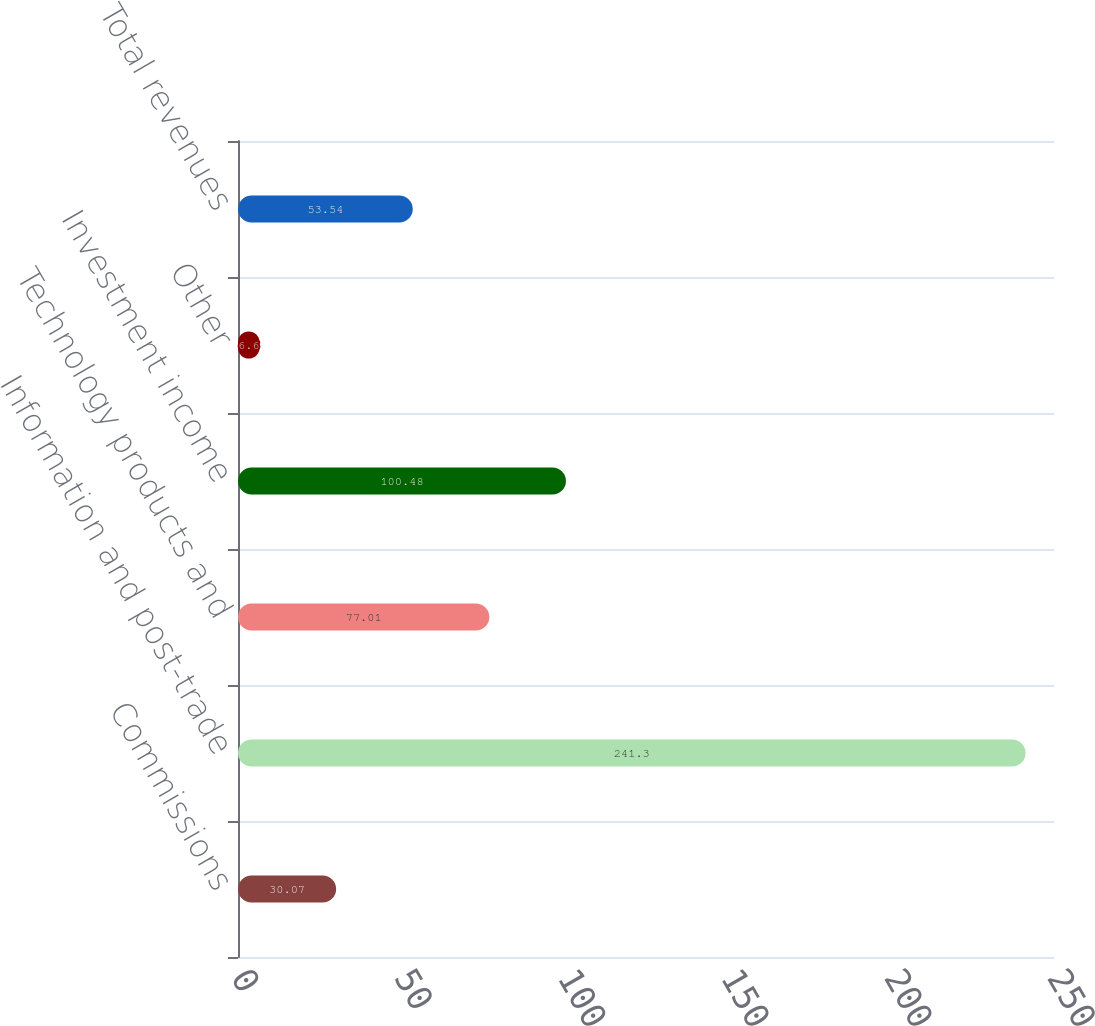Convert chart to OTSL. <chart><loc_0><loc_0><loc_500><loc_500><bar_chart><fcel>Commissions<fcel>Information and post-trade<fcel>Technology products and<fcel>Investment income<fcel>Other<fcel>Total revenues<nl><fcel>30.07<fcel>241.3<fcel>77.01<fcel>100.48<fcel>6.6<fcel>53.54<nl></chart> 